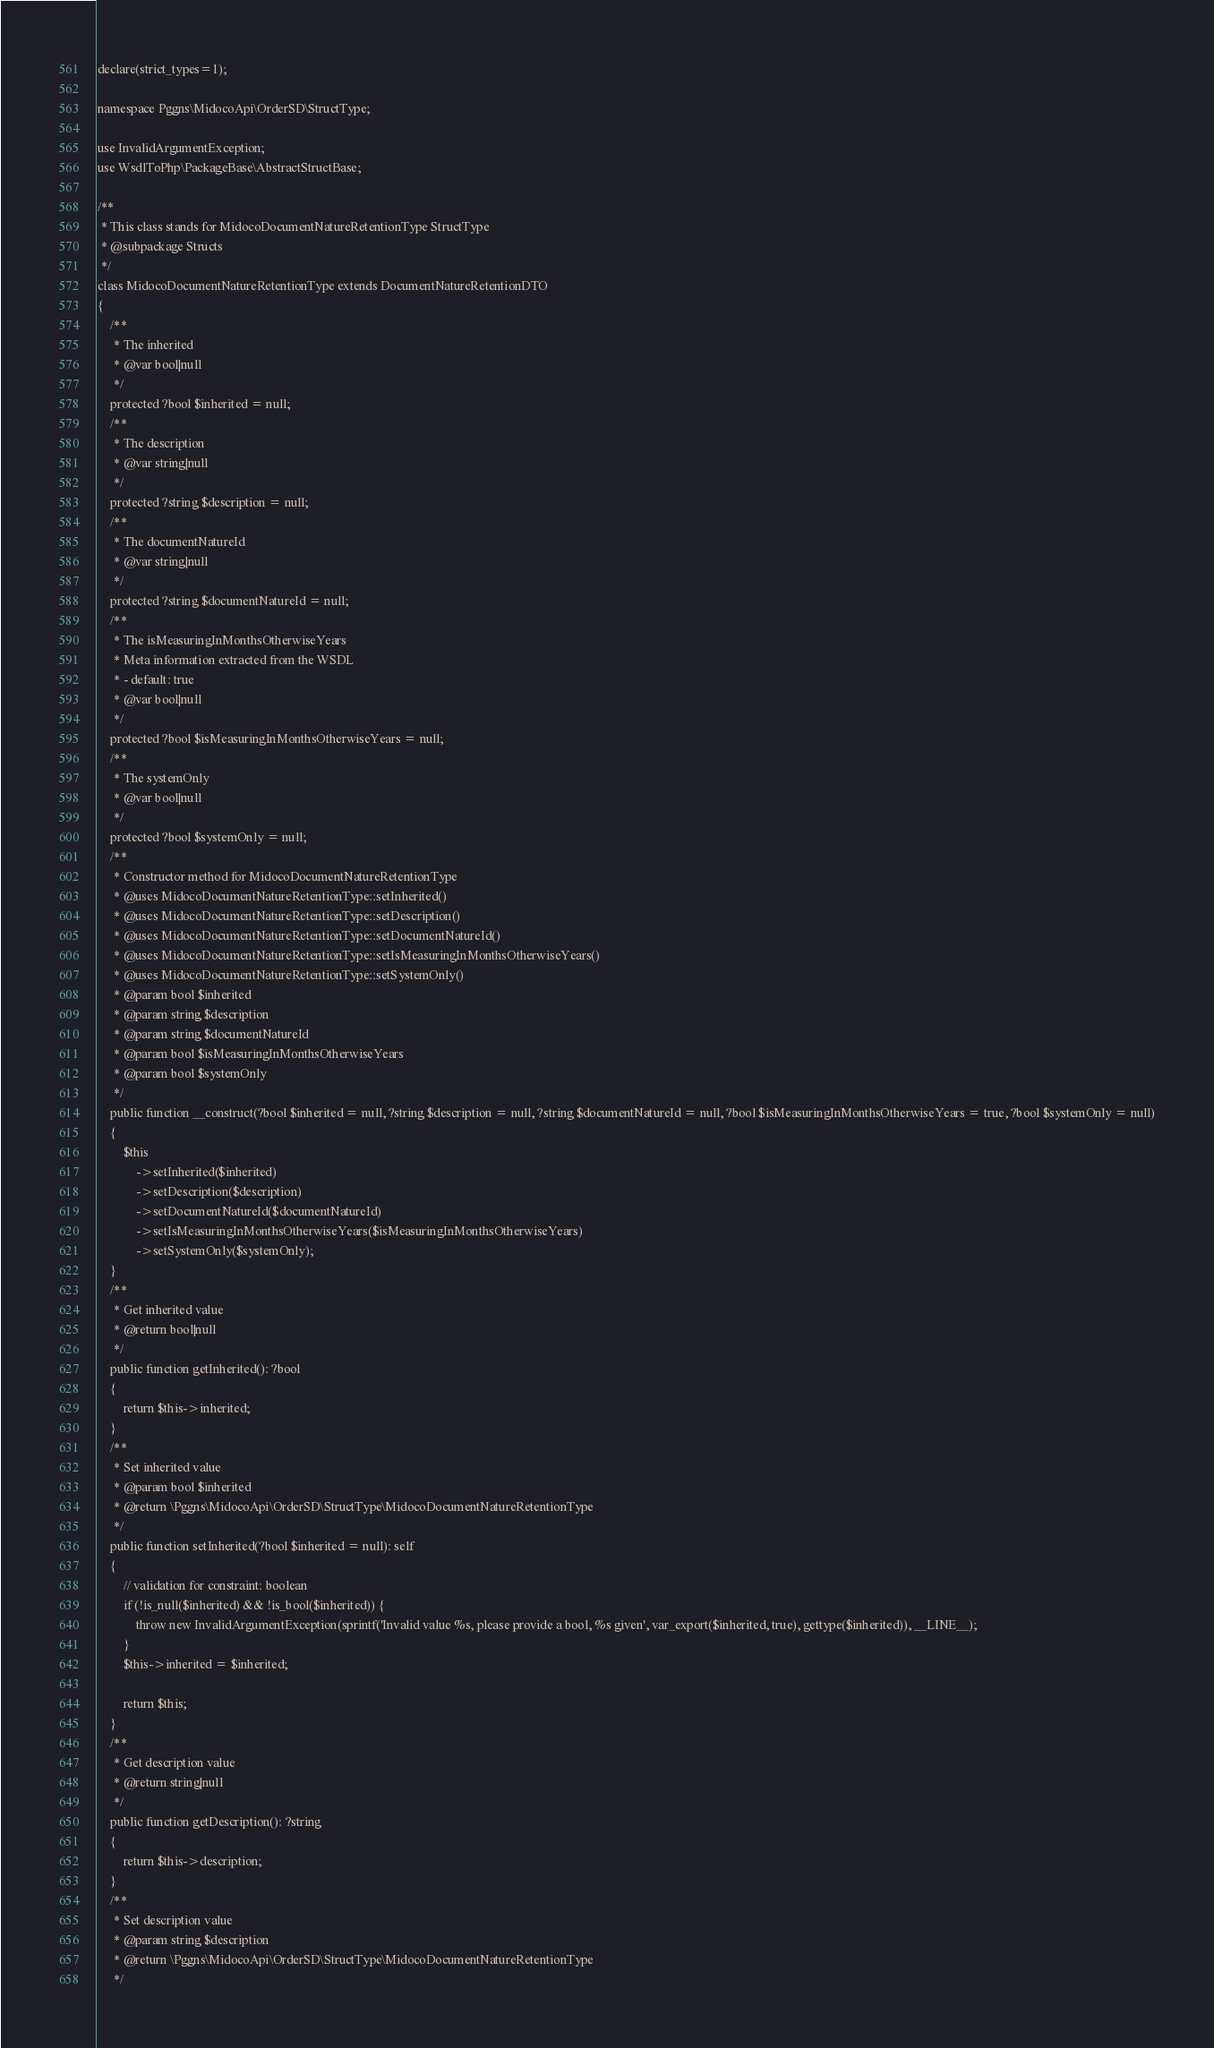<code> <loc_0><loc_0><loc_500><loc_500><_PHP_>
declare(strict_types=1);

namespace Pggns\MidocoApi\OrderSD\StructType;

use InvalidArgumentException;
use WsdlToPhp\PackageBase\AbstractStructBase;

/**
 * This class stands for MidocoDocumentNatureRetentionType StructType
 * @subpackage Structs
 */
class MidocoDocumentNatureRetentionType extends DocumentNatureRetentionDTO
{
    /**
     * The inherited
     * @var bool|null
     */
    protected ?bool $inherited = null;
    /**
     * The description
     * @var string|null
     */
    protected ?string $description = null;
    /**
     * The documentNatureId
     * @var string|null
     */
    protected ?string $documentNatureId = null;
    /**
     * The isMeasuringInMonthsOtherwiseYears
     * Meta information extracted from the WSDL
     * - default: true
     * @var bool|null
     */
    protected ?bool $isMeasuringInMonthsOtherwiseYears = null;
    /**
     * The systemOnly
     * @var bool|null
     */
    protected ?bool $systemOnly = null;
    /**
     * Constructor method for MidocoDocumentNatureRetentionType
     * @uses MidocoDocumentNatureRetentionType::setInherited()
     * @uses MidocoDocumentNatureRetentionType::setDescription()
     * @uses MidocoDocumentNatureRetentionType::setDocumentNatureId()
     * @uses MidocoDocumentNatureRetentionType::setIsMeasuringInMonthsOtherwiseYears()
     * @uses MidocoDocumentNatureRetentionType::setSystemOnly()
     * @param bool $inherited
     * @param string $description
     * @param string $documentNatureId
     * @param bool $isMeasuringInMonthsOtherwiseYears
     * @param bool $systemOnly
     */
    public function __construct(?bool $inherited = null, ?string $description = null, ?string $documentNatureId = null, ?bool $isMeasuringInMonthsOtherwiseYears = true, ?bool $systemOnly = null)
    {
        $this
            ->setInherited($inherited)
            ->setDescription($description)
            ->setDocumentNatureId($documentNatureId)
            ->setIsMeasuringInMonthsOtherwiseYears($isMeasuringInMonthsOtherwiseYears)
            ->setSystemOnly($systemOnly);
    }
    /**
     * Get inherited value
     * @return bool|null
     */
    public function getInherited(): ?bool
    {
        return $this->inherited;
    }
    /**
     * Set inherited value
     * @param bool $inherited
     * @return \Pggns\MidocoApi\OrderSD\StructType\MidocoDocumentNatureRetentionType
     */
    public function setInherited(?bool $inherited = null): self
    {
        // validation for constraint: boolean
        if (!is_null($inherited) && !is_bool($inherited)) {
            throw new InvalidArgumentException(sprintf('Invalid value %s, please provide a bool, %s given', var_export($inherited, true), gettype($inherited)), __LINE__);
        }
        $this->inherited = $inherited;
        
        return $this;
    }
    /**
     * Get description value
     * @return string|null
     */
    public function getDescription(): ?string
    {
        return $this->description;
    }
    /**
     * Set description value
     * @param string $description
     * @return \Pggns\MidocoApi\OrderSD\StructType\MidocoDocumentNatureRetentionType
     */</code> 